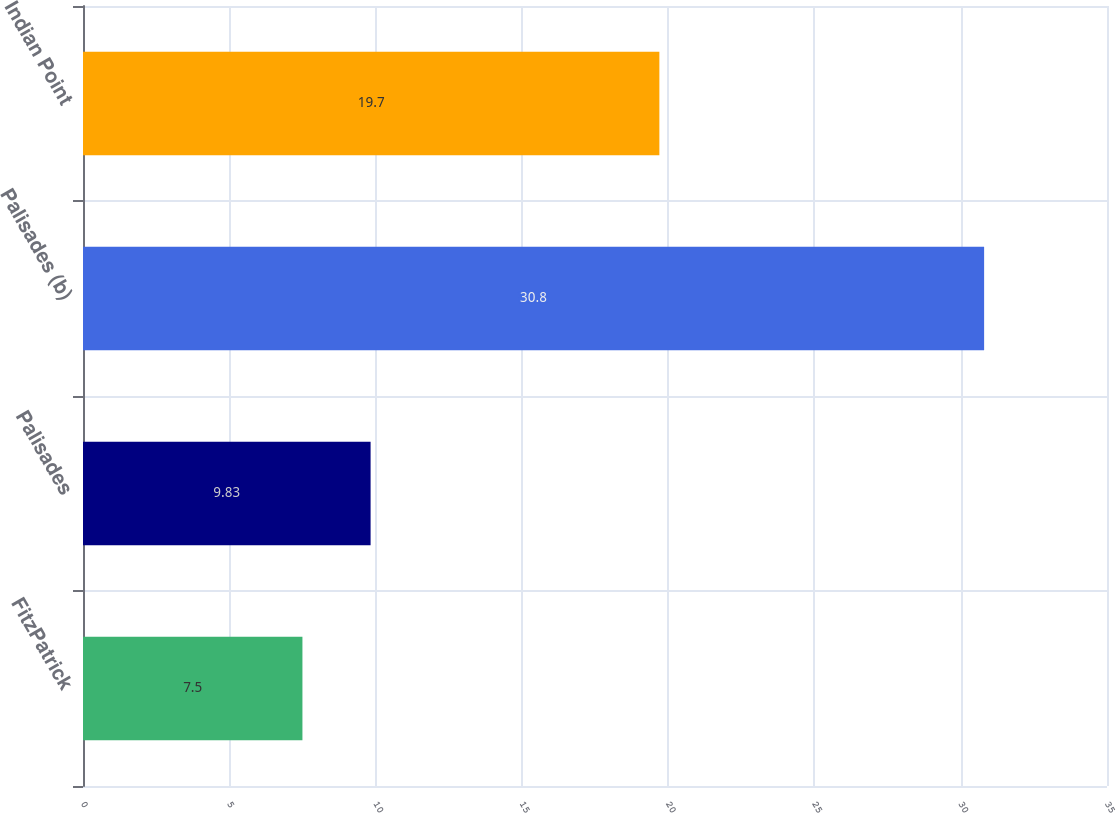Convert chart. <chart><loc_0><loc_0><loc_500><loc_500><bar_chart><fcel>FitzPatrick<fcel>Palisades<fcel>Palisades (b)<fcel>Indian Point<nl><fcel>7.5<fcel>9.83<fcel>30.8<fcel>19.7<nl></chart> 